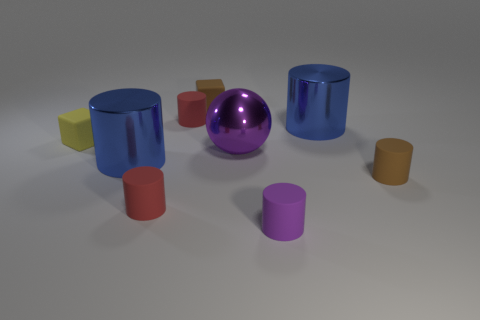There is a object that is the same color as the metallic ball; what is its shape?
Your answer should be compact. Cylinder. Is there anything else that is made of the same material as the yellow block?
Give a very brief answer. Yes. Do the big ball and the tiny yellow thing have the same material?
Offer a very short reply. No. What shape is the brown thing that is behind the large blue shiny cylinder that is to the right of the large metal cylinder that is on the left side of the tiny purple cylinder?
Keep it short and to the point. Cube. Is the number of tiny brown objects that are left of the ball less than the number of matte things to the right of the small purple matte cylinder?
Provide a short and direct response. No. What is the shape of the small brown object on the right side of the blue thing that is to the right of the purple shiny object?
Keep it short and to the point. Cylinder. Are there any other things of the same color as the ball?
Your response must be concise. Yes. What number of gray things are either large metallic things or cubes?
Provide a succinct answer. 0. Are there fewer yellow matte blocks in front of the yellow matte block than large blue things?
Keep it short and to the point. Yes. There is a tiny red matte cylinder in front of the yellow matte thing; what number of matte cylinders are behind it?
Provide a succinct answer. 2. 